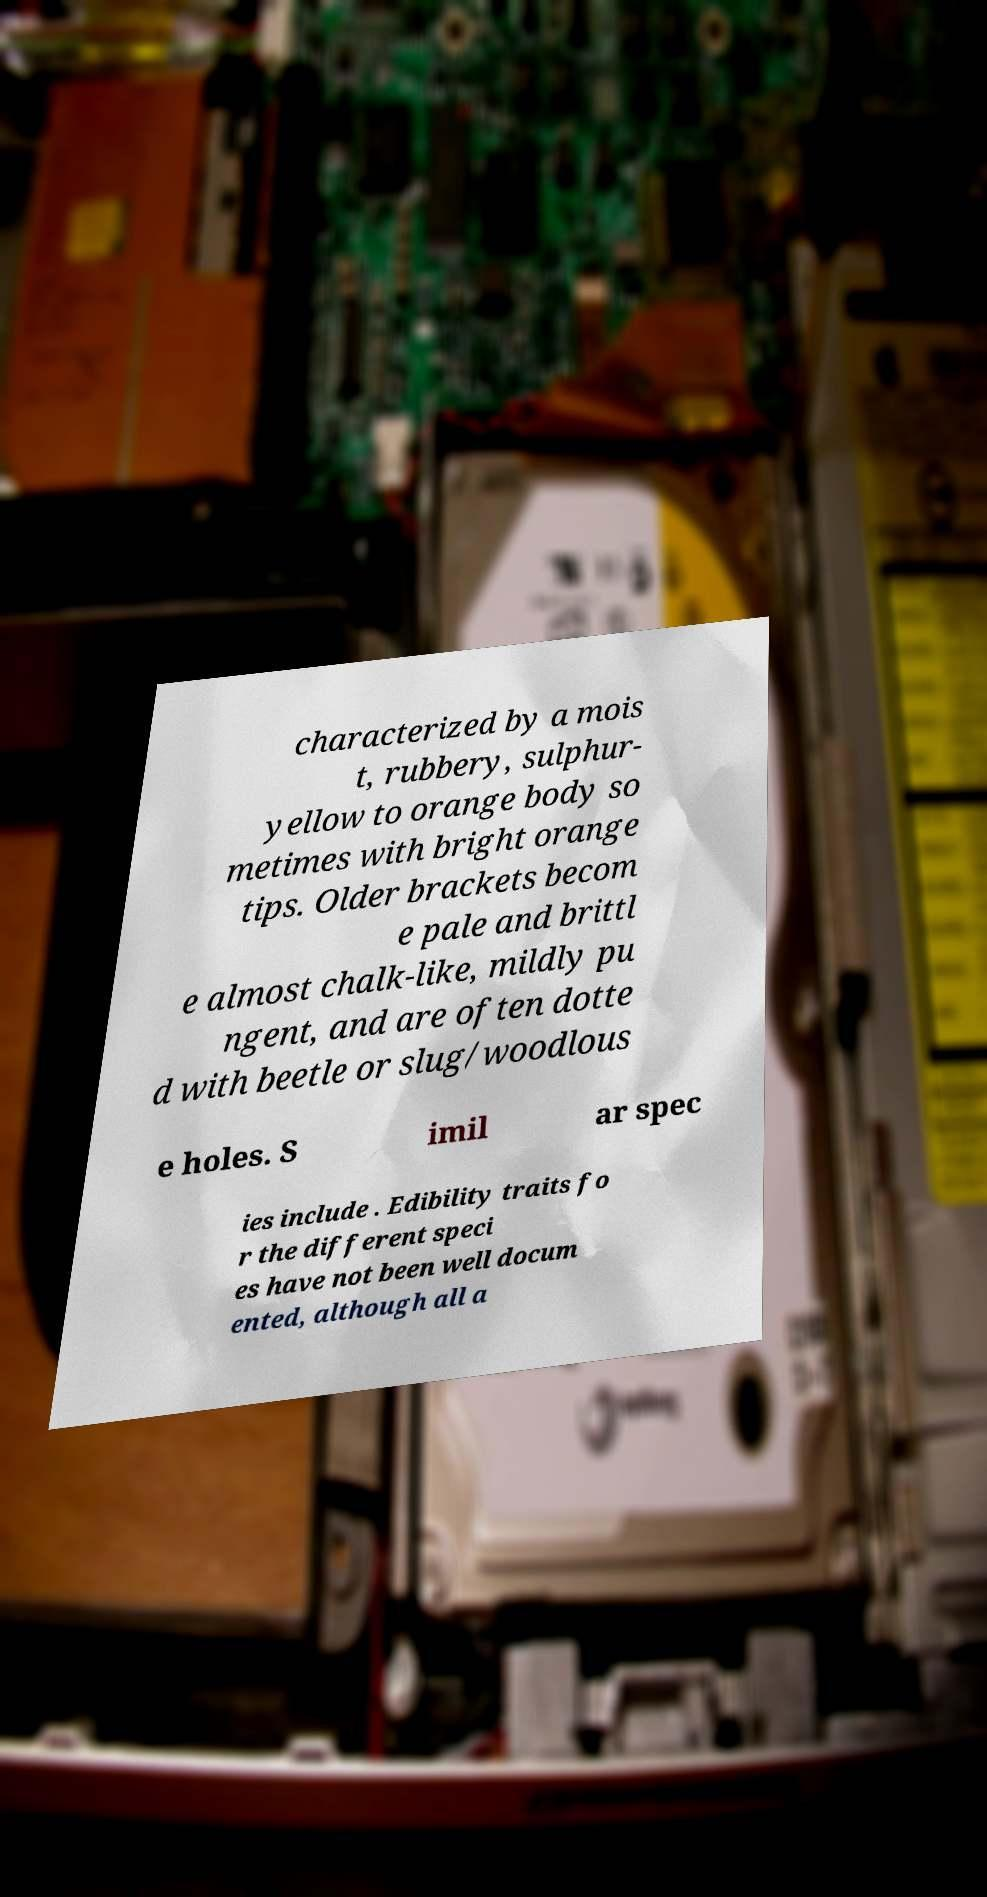Can you read and provide the text displayed in the image?This photo seems to have some interesting text. Can you extract and type it out for me? characterized by a mois t, rubbery, sulphur- yellow to orange body so metimes with bright orange tips. Older brackets becom e pale and brittl e almost chalk-like, mildly pu ngent, and are often dotte d with beetle or slug/woodlous e holes. S imil ar spec ies include . Edibility traits fo r the different speci es have not been well docum ented, although all a 